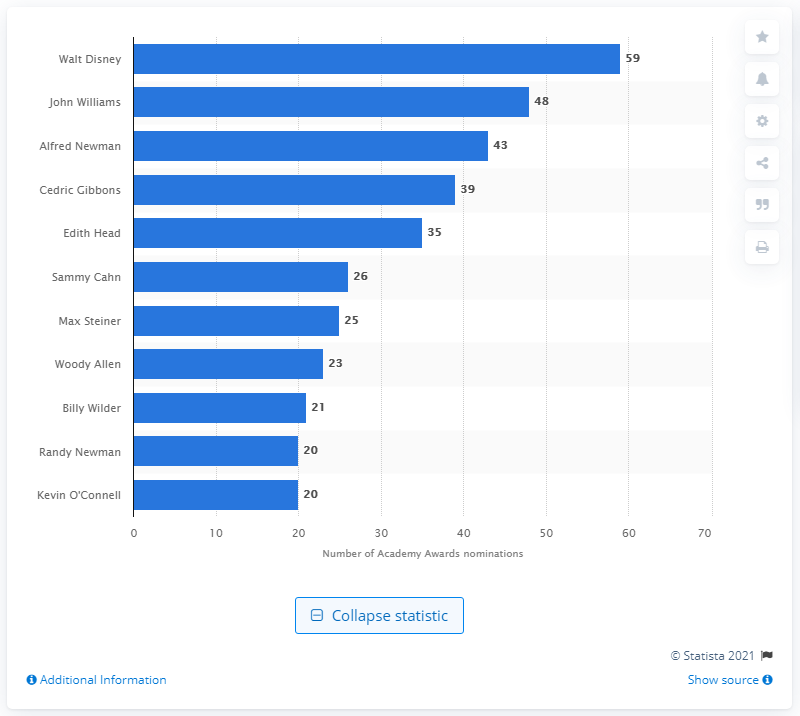Mention a couple of crucial points in this snapshot. Walt Disney was nominated for an Academy Award a total of 26 times and won for several of his films. Kevin O'Connell is the only person in the ranking who has not yet received an Oscar. Walt Disney was nominated for 59 Academy Awards and won 22 of them. 